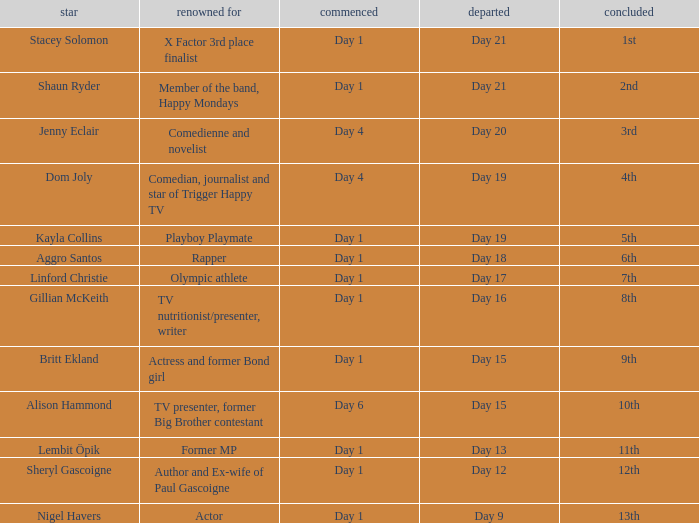Can you parse all the data within this table? {'header': ['star', 'renowned for', 'commenced', 'departed', 'concluded'], 'rows': [['Stacey Solomon', 'X Factor 3rd place finalist', 'Day 1', 'Day 21', '1st'], ['Shaun Ryder', 'Member of the band, Happy Mondays', 'Day 1', 'Day 21', '2nd'], ['Jenny Eclair', 'Comedienne and novelist', 'Day 4', 'Day 20', '3rd'], ['Dom Joly', 'Comedian, journalist and star of Trigger Happy TV', 'Day 4', 'Day 19', '4th'], ['Kayla Collins', 'Playboy Playmate', 'Day 1', 'Day 19', '5th'], ['Aggro Santos', 'Rapper', 'Day 1', 'Day 18', '6th'], ['Linford Christie', 'Olympic athlete', 'Day 1', 'Day 17', '7th'], ['Gillian McKeith', 'TV nutritionist/presenter, writer', 'Day 1', 'Day 16', '8th'], ['Britt Ekland', 'Actress and former Bond girl', 'Day 1', 'Day 15', '9th'], ['Alison Hammond', 'TV presenter, former Big Brother contestant', 'Day 6', 'Day 15', '10th'], ['Lembit Öpik', 'Former MP', 'Day 1', 'Day 13', '11th'], ['Sheryl Gascoigne', 'Author and Ex-wife of Paul Gascoigne', 'Day 1', 'Day 12', '12th'], ['Nigel Havers', 'Actor', 'Day 1', 'Day 9', '13th']]} What celebrity is famous for being an actor? Nigel Havers. 